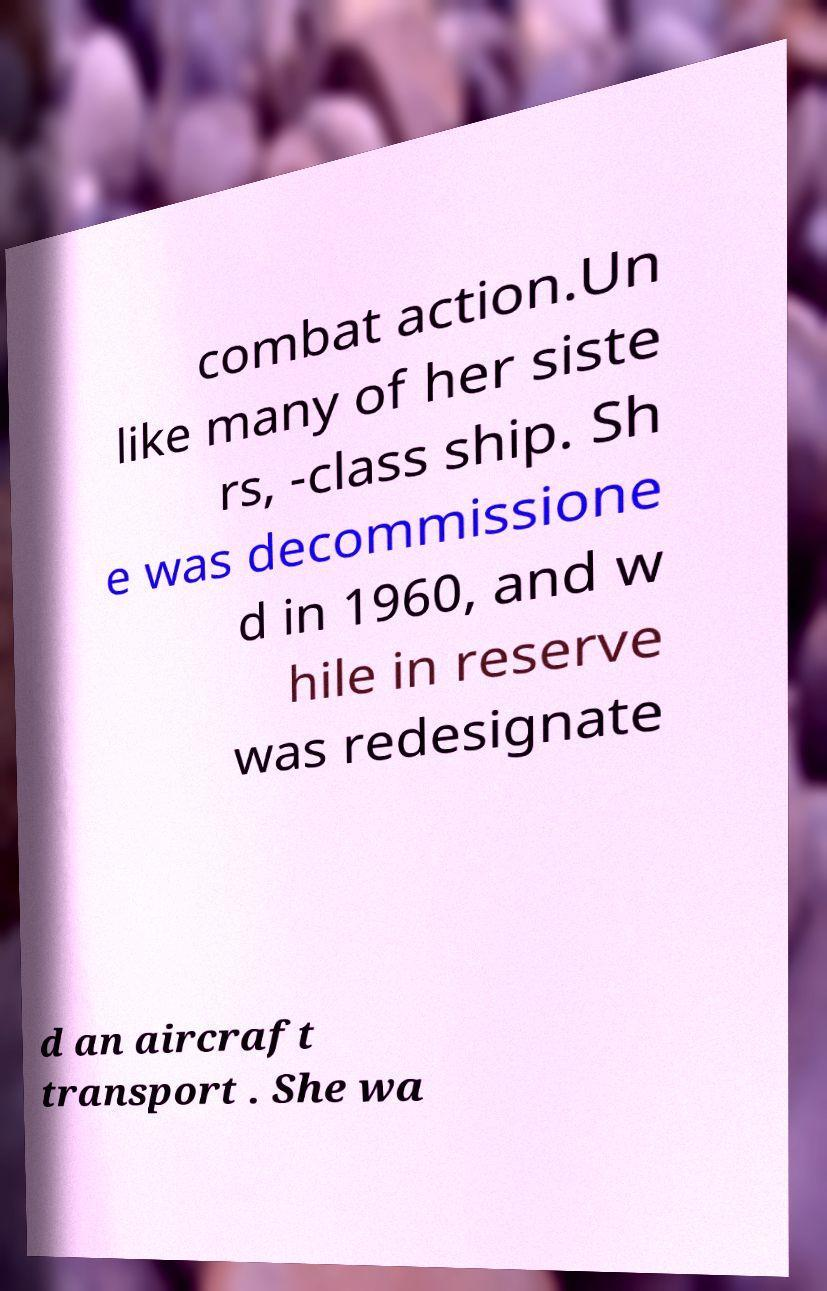There's text embedded in this image that I need extracted. Can you transcribe it verbatim? combat action.Un like many of her siste rs, -class ship. Sh e was decommissione d in 1960, and w hile in reserve was redesignate d an aircraft transport . She wa 